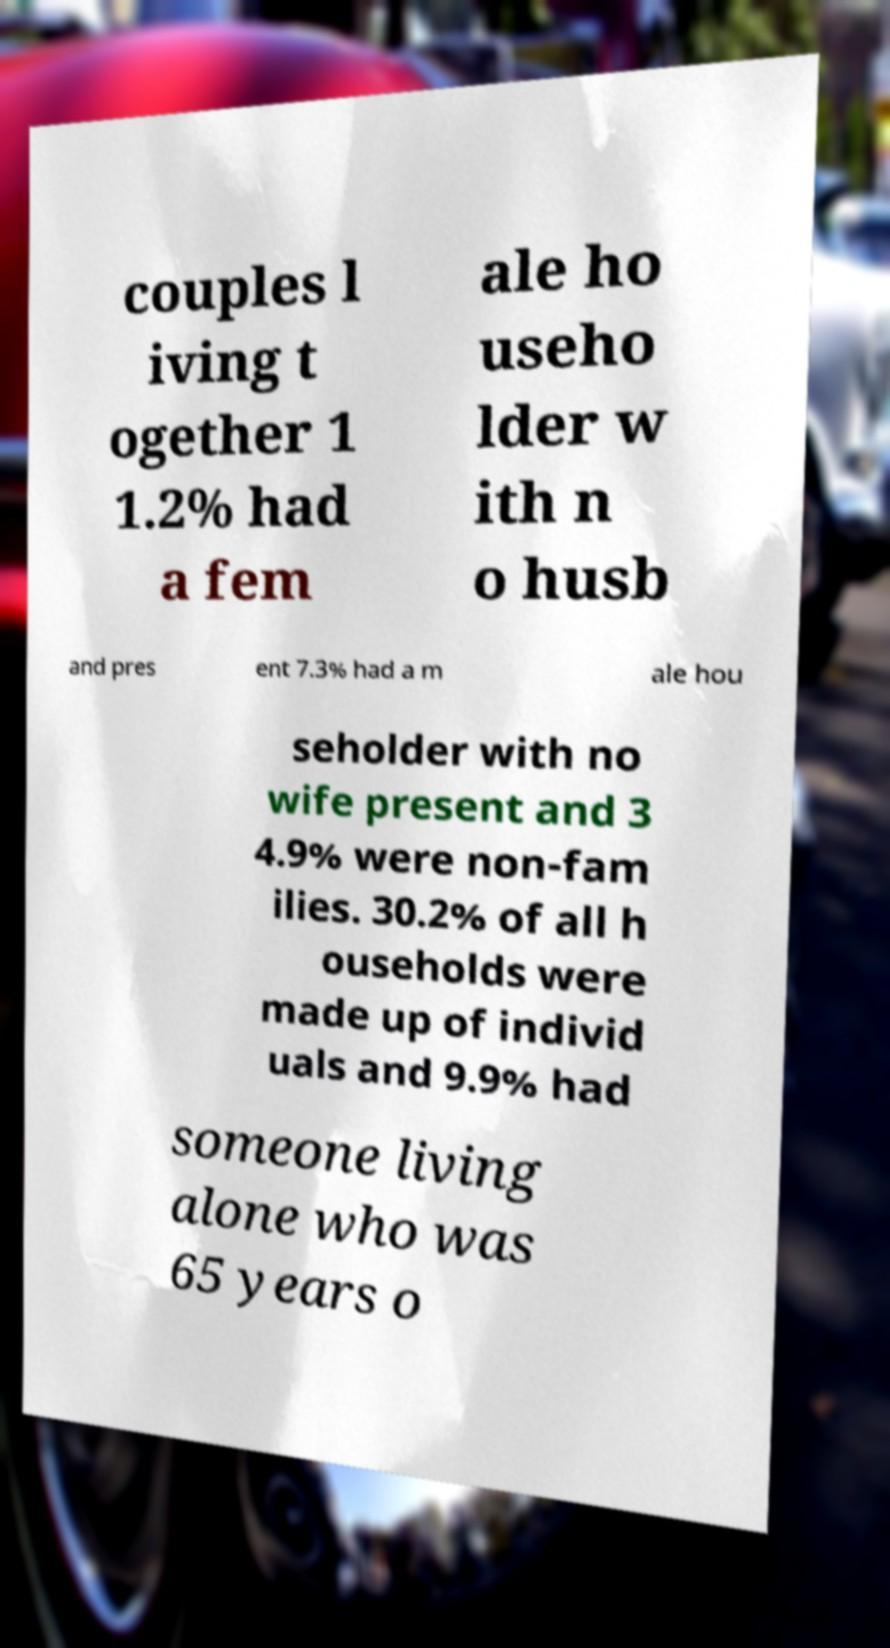Please identify and transcribe the text found in this image. couples l iving t ogether 1 1.2% had a fem ale ho useho lder w ith n o husb and pres ent 7.3% had a m ale hou seholder with no wife present and 3 4.9% were non-fam ilies. 30.2% of all h ouseholds were made up of individ uals and 9.9% had someone living alone who was 65 years o 